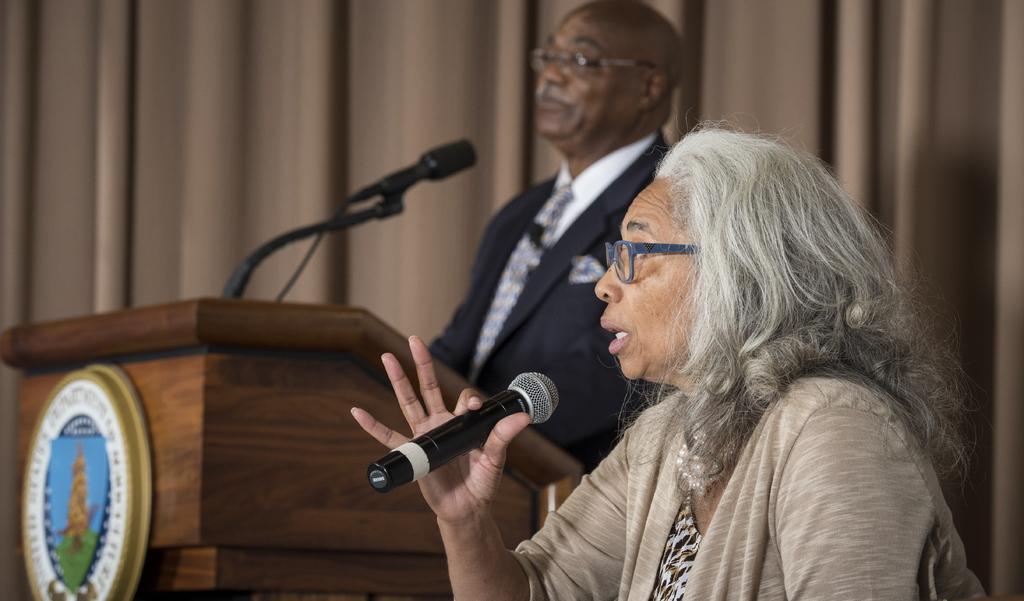Could you give a brief overview of what you see in this image? On the right side of the image a lady is holding a mic and wearing spectacles. In the center of the image a man is there in-front of podium. On podium we can see a mic. In the background of the image we can see a curtain. 